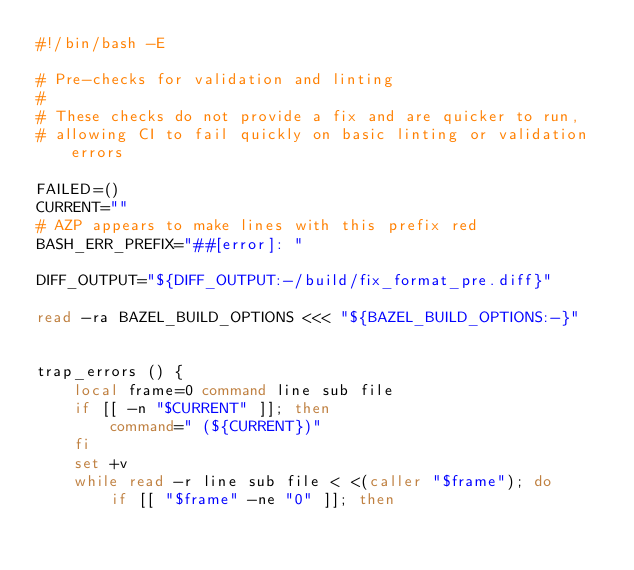Convert code to text. <code><loc_0><loc_0><loc_500><loc_500><_Bash_>#!/bin/bash -E

# Pre-checks for validation and linting
#
# These checks do not provide a fix and are quicker to run,
# allowing CI to fail quickly on basic linting or validation errors

FAILED=()
CURRENT=""
# AZP appears to make lines with this prefix red
BASH_ERR_PREFIX="##[error]: "

DIFF_OUTPUT="${DIFF_OUTPUT:-/build/fix_format_pre.diff}"

read -ra BAZEL_BUILD_OPTIONS <<< "${BAZEL_BUILD_OPTIONS:-}"


trap_errors () {
    local frame=0 command line sub file
    if [[ -n "$CURRENT" ]]; then
        command=" (${CURRENT})"
    fi
    set +v
    while read -r line sub file < <(caller "$frame"); do
        if [[ "$frame" -ne "0" ]]; then</code> 